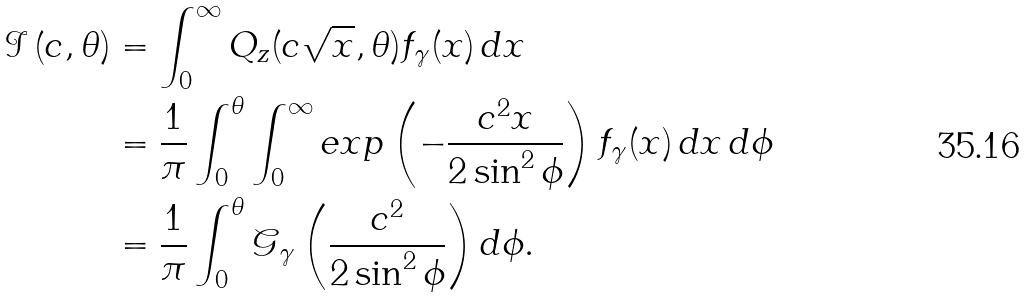Convert formula to latex. <formula><loc_0><loc_0><loc_500><loc_500>\mathcal { I } \left ( c , \theta \right ) & = \int _ { 0 } ^ { \infty } Q _ { z } ( c \sqrt { x } , \theta ) f _ { \gamma } ( x ) \, d x \\ & = \frac { 1 } { \pi } \int _ { 0 } ^ { \theta } \int _ { 0 } ^ { \infty } e x p \left ( - \frac { c ^ { 2 } x } { 2 \sin ^ { 2 } \phi } \right ) f _ { \gamma } ( x ) \, d x \, d \phi \\ & = \frac { 1 } { \pi } \int _ { 0 } ^ { \theta } \mathcal { G } _ { \gamma } \left ( \frac { c ^ { 2 } } { 2 \sin ^ { 2 } \phi } \right ) d \phi .</formula> 